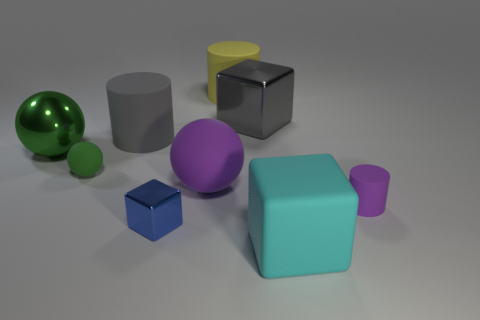Subtract all large gray metal blocks. How many blocks are left? 2 Subtract all blue cylinders. How many green balls are left? 2 Add 1 blue rubber cubes. How many objects exist? 10 Subtract all purple cylinders. How many cylinders are left? 2 Subtract all blocks. How many objects are left? 6 Subtract all yellow balls. Subtract all brown cubes. How many balls are left? 3 Add 6 tiny blue shiny blocks. How many tiny blue shiny blocks are left? 7 Add 7 small green rubber objects. How many small green rubber objects exist? 8 Subtract 1 yellow cylinders. How many objects are left? 8 Subtract all tiny green metal cubes. Subtract all large cyan rubber objects. How many objects are left? 8 